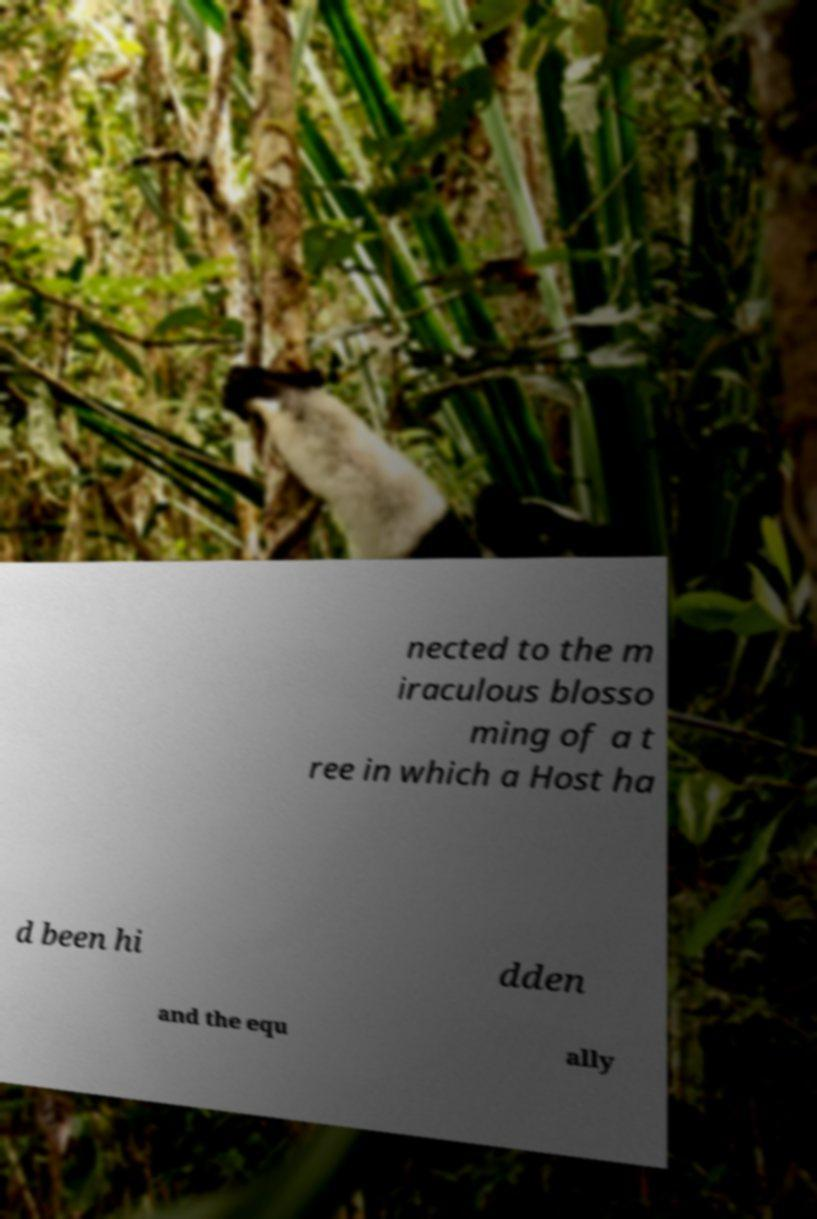What messages or text are displayed in this image? I need them in a readable, typed format. nected to the m iraculous blosso ming of a t ree in which a Host ha d been hi dden and the equ ally 